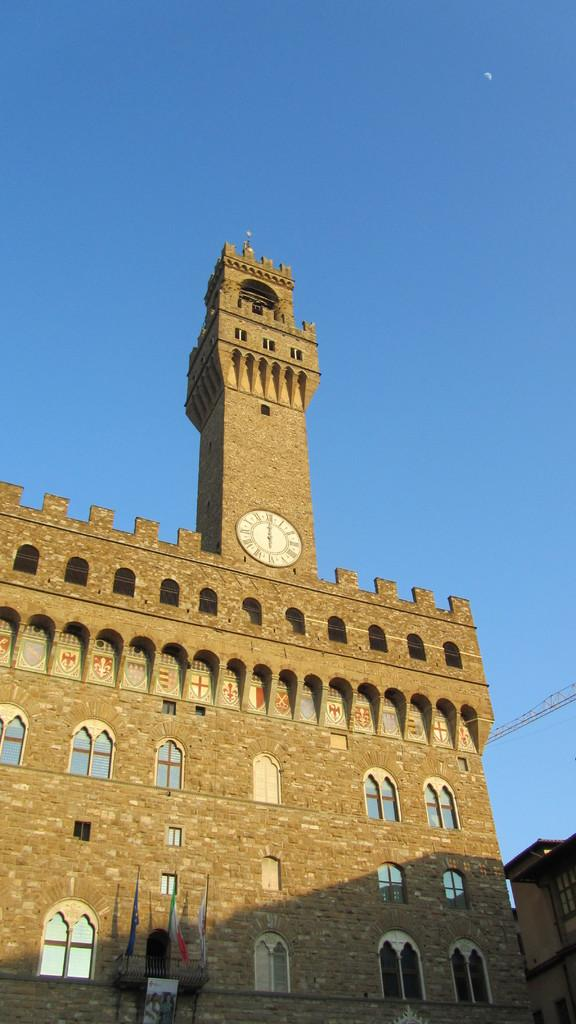What type of structures are visible in the image? There are buildings in the image. What feature can be seen on the buildings? There are windows visible on the buildings. What time-telling device is present in the image? There is a clock in the image. What part of the natural environment is visible in the image? The sky is visible in the image. Based on the presence of the sky and the absence of artificial lighting, can we infer the time of day when the image was taken? Yes, the image was likely taken during the day. What type of activity is the grandmother doing with the dime in the image? There is no grandmother or dime present in the image. 